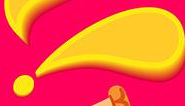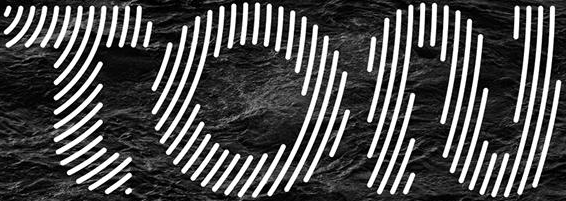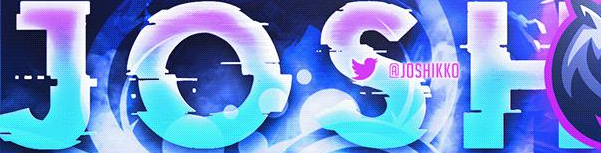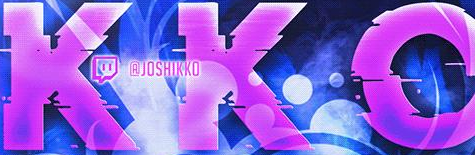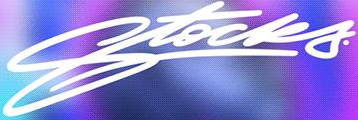What words can you see in these images in sequence, separated by a semicolon? !; TON; JOSH; KKO; Stocks 